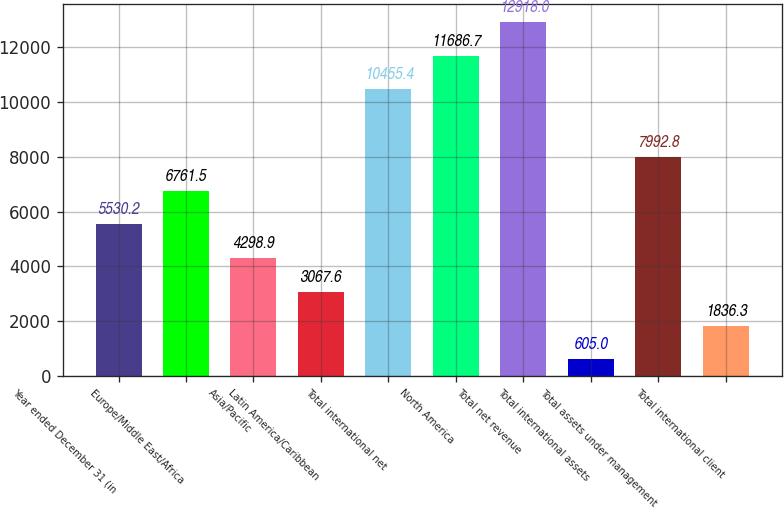Convert chart to OTSL. <chart><loc_0><loc_0><loc_500><loc_500><bar_chart><fcel>Year ended December 31 (in<fcel>Europe/Middle East/Africa<fcel>Asia/Pacific<fcel>Latin America/Caribbean<fcel>Total international net<fcel>North America<fcel>Total net revenue<fcel>Total international assets<fcel>Total assets under management<fcel>Total international client<nl><fcel>5530.2<fcel>6761.5<fcel>4298.9<fcel>3067.6<fcel>10455.4<fcel>11686.7<fcel>12918<fcel>605<fcel>7992.8<fcel>1836.3<nl></chart> 